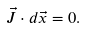<formula> <loc_0><loc_0><loc_500><loc_500>\vec { J } \cdot d \vec { x } = 0 .</formula> 